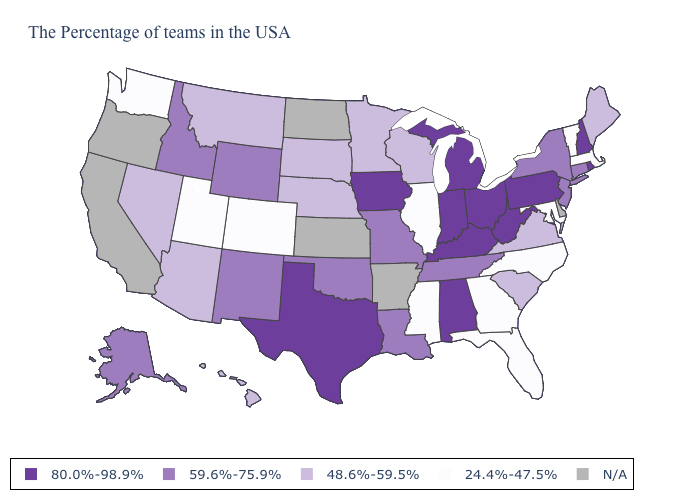What is the highest value in the USA?
Concise answer only. 80.0%-98.9%. Name the states that have a value in the range 24.4%-47.5%?
Give a very brief answer. Massachusetts, Vermont, Maryland, North Carolina, Florida, Georgia, Illinois, Mississippi, Colorado, Utah, Washington. Which states hav the highest value in the West?
Short answer required. Wyoming, New Mexico, Idaho, Alaska. Among the states that border Wyoming , does Colorado have the lowest value?
Concise answer only. Yes. Does Indiana have the highest value in the USA?
Short answer required. Yes. Does Montana have the lowest value in the USA?
Concise answer only. No. What is the value of Michigan?
Answer briefly. 80.0%-98.9%. Name the states that have a value in the range 24.4%-47.5%?
Be succinct. Massachusetts, Vermont, Maryland, North Carolina, Florida, Georgia, Illinois, Mississippi, Colorado, Utah, Washington. What is the highest value in the South ?
Concise answer only. 80.0%-98.9%. Name the states that have a value in the range 59.6%-75.9%?
Short answer required. Connecticut, New York, New Jersey, Tennessee, Louisiana, Missouri, Oklahoma, Wyoming, New Mexico, Idaho, Alaska. Among the states that border Georgia , does North Carolina have the lowest value?
Be succinct. Yes. Does the map have missing data?
Write a very short answer. Yes. Name the states that have a value in the range 48.6%-59.5%?
Keep it brief. Maine, Virginia, South Carolina, Wisconsin, Minnesota, Nebraska, South Dakota, Montana, Arizona, Nevada, Hawaii. What is the value of North Dakota?
Keep it brief. N/A. What is the lowest value in the USA?
Write a very short answer. 24.4%-47.5%. 